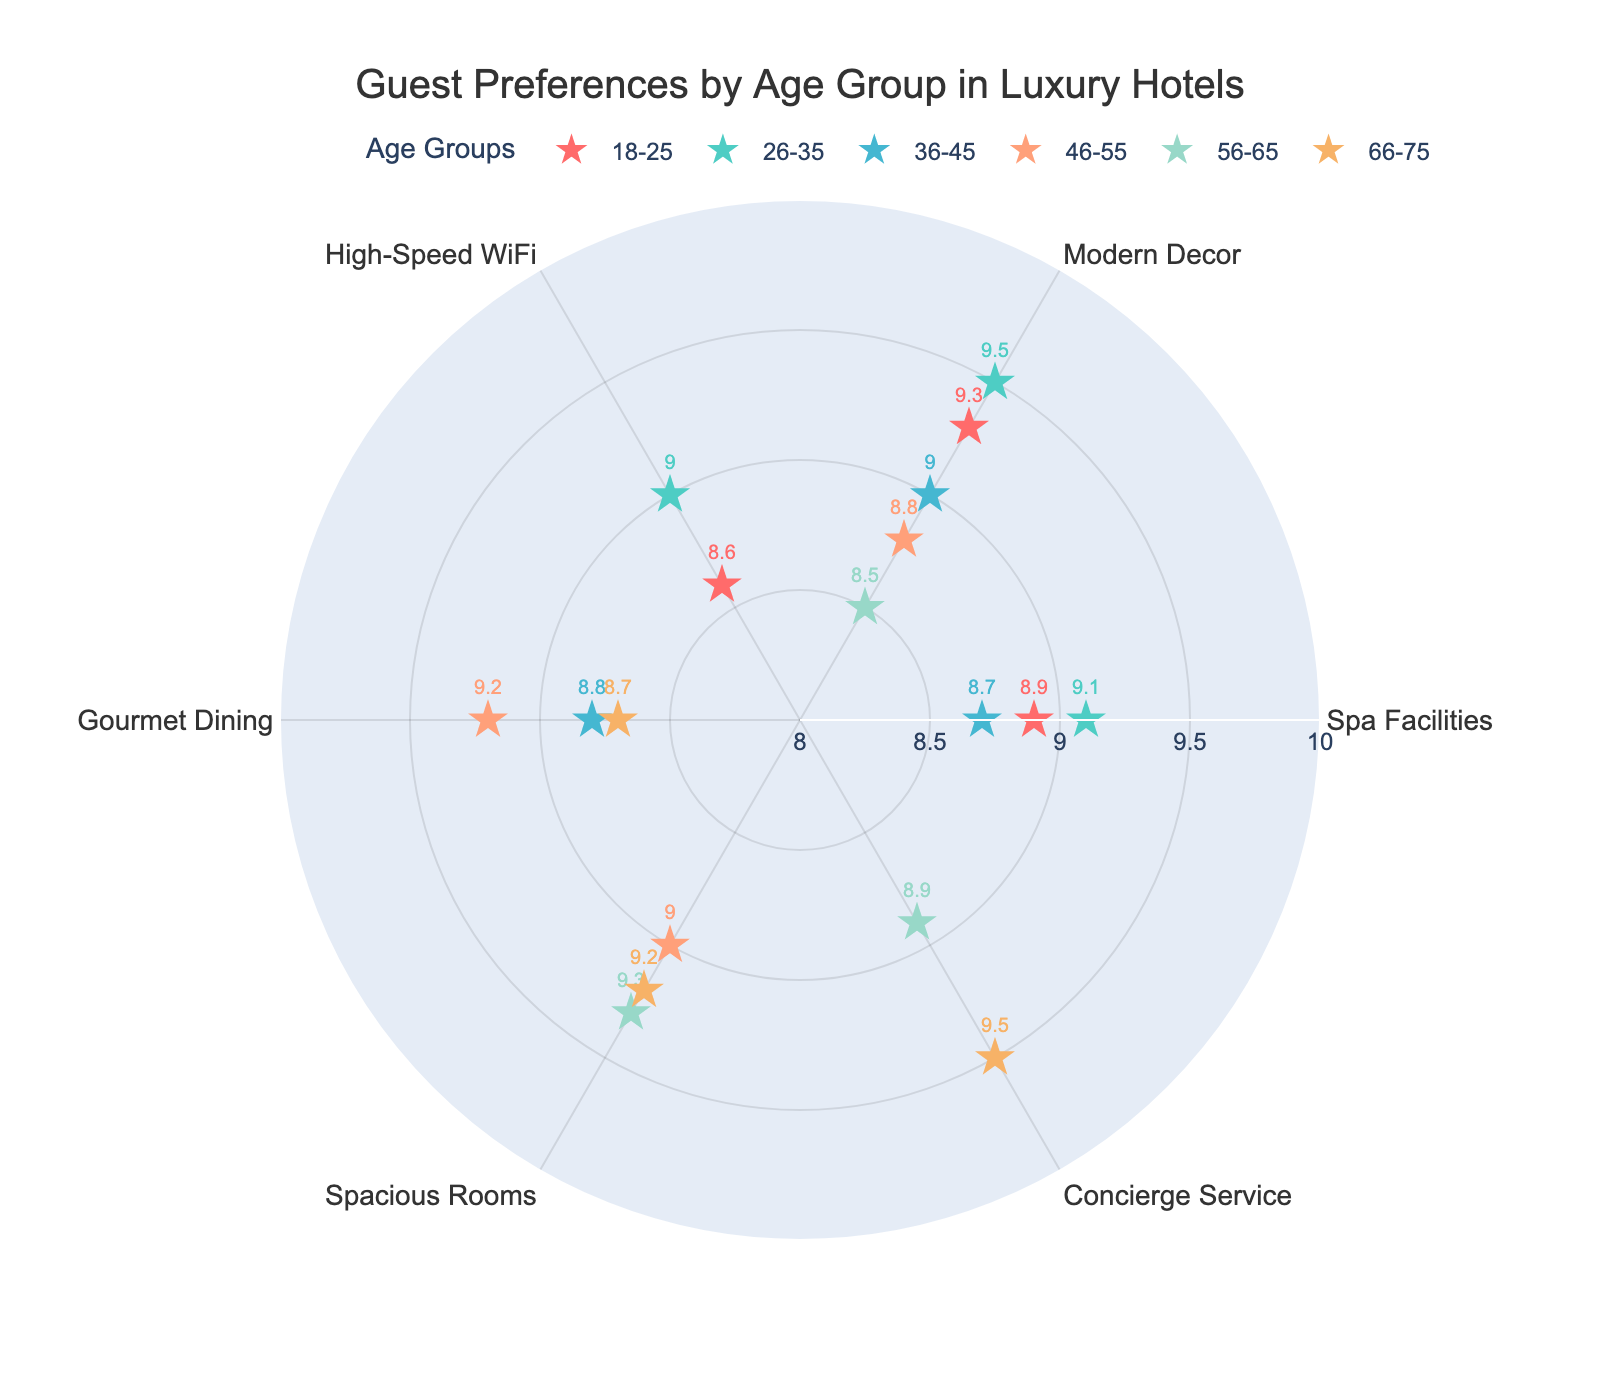What's the highest preference score for the 26-35 age group? The markers for the 26-35 age group are colored in a shade of teal. Looking at the teal markers, the highest preference score shown is 9.5 for Modern Decor.
Answer: 9.5 Which age group has the highest score for Concierge Service? The data points for Concierge Service can be found at specific radial distances on the chart. The highest score for Concierge Service comes from the 66-75 age group, which scores 9.5.
Answer: 66-75 How does the preference score for Modern Decor in the 56-65 age group compare to that in the 18-25 age group? The markers for Modern Decor in the 56-65 age group have a score of 8.5, while in the 18-25 age group, it is 9.3. Thus, the 56-65 age group's preference for Modern Decor is lower.
Answer: 8.5 is less than 9.3 Which age group shows a preference for Gourmet Dining, and what are their scores? The dots for Gourmet Dining can be identified by the associated radial distance values. The groups that show a preference for Gourmet Dining are 36-45 with a score of 8.8, 46-55 with a score of 9.2, and 66-75 with a score of 8.7.
Answer: 36-45 (8.8), 46-55 (9.2), 66-75 (8.7) What is the average preference score for Spa Facilities among the groups? The scores for Spa Facilities are 8.9 (18-25), 9.1 (26-35), and 8.7 (36-45). Adding these scores gives 26.7, and the average is 26.7/3 = 8.9.
Answer: 8.9 Which age group has the most varied preferences and why? The most varied preferences would be indicated by the age group with data points spanning the widest range of preference scores. The 46-55 age group has preferences for Gourmet Dining (9.2), Spacious Rooms (9.0), and Modern Decor (8.8), showing a varied set of interests.
Answer: 46-55 What is the most popular luxury hotel feature among the 18-25 age group? The markers for the 18-25 age group indicate preferences with the highest score being 9.3 for Modern Decor.
Answer: Modern Decor How many different age groups have preferences that include Spacious Rooms? Spacious Rooms is a preference for the 46-55, 56-65, and 66-75 age groups. Hence, there are 3 age groups that include Spacious Rooms in their preferences.
Answer: 3 Which two age groups have the closest preference scores for any given hotel feature, and what is that feature? Looking at the overlay of data points, the preference scores for Spa Facilities for the 18-25 and 36-45 age groups are 8.9 and 8.7, respectively. Hence, they have close scores.
Answer: 18-25 and 36-45 for Spa Facilities 